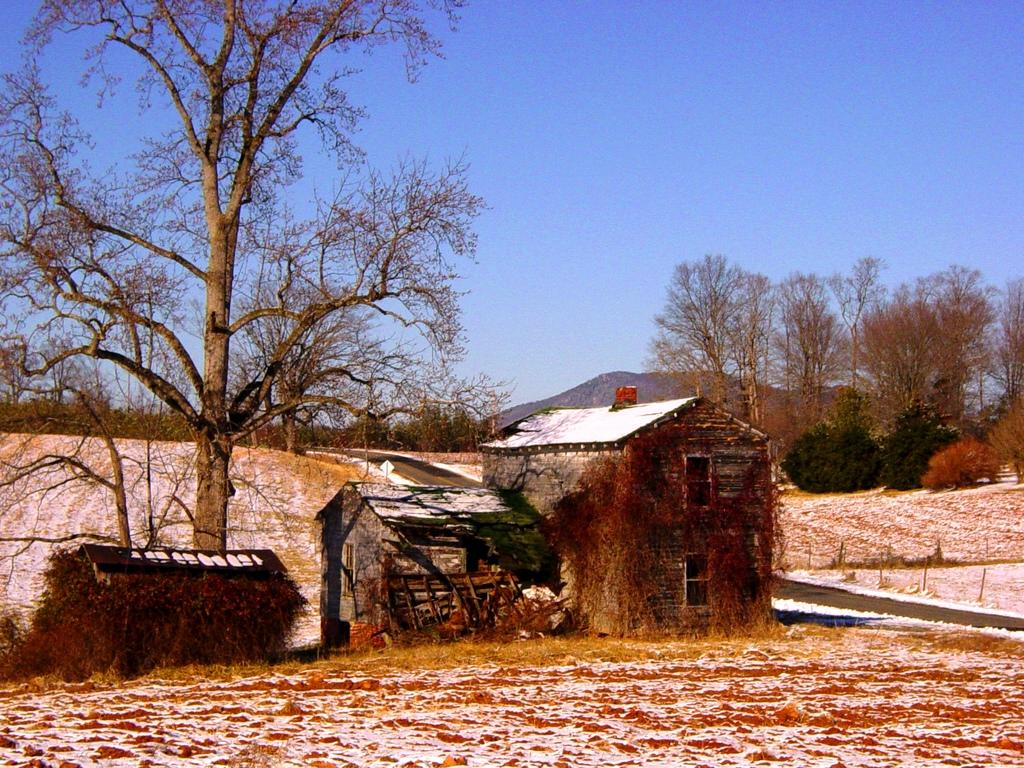What type of structures can be seen in the image? There are houses in the image. What is the main pathway visible in the image? There is a road in the image. What type of vegetation is present in the image? There is grass and trees in the image. What can be seen in the distance in the image? There is a hill visible in the background of the image. What is visible above the hill in the image? The sky is visible in the background of the image. What type of oatmeal is being served on the hill in the image? There is no oatmeal present in the image; it features houses, a road, grass, trees, a hill, and the sky. How many icicles are hanging from the trees in the image? There are no icicles present in the image; it is not winter or cold enough for icicles to form. 